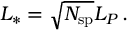<formula> <loc_0><loc_0><loc_500><loc_500>L _ { * } = \sqrt { N _ { s p } } L _ { P } \, .</formula> 